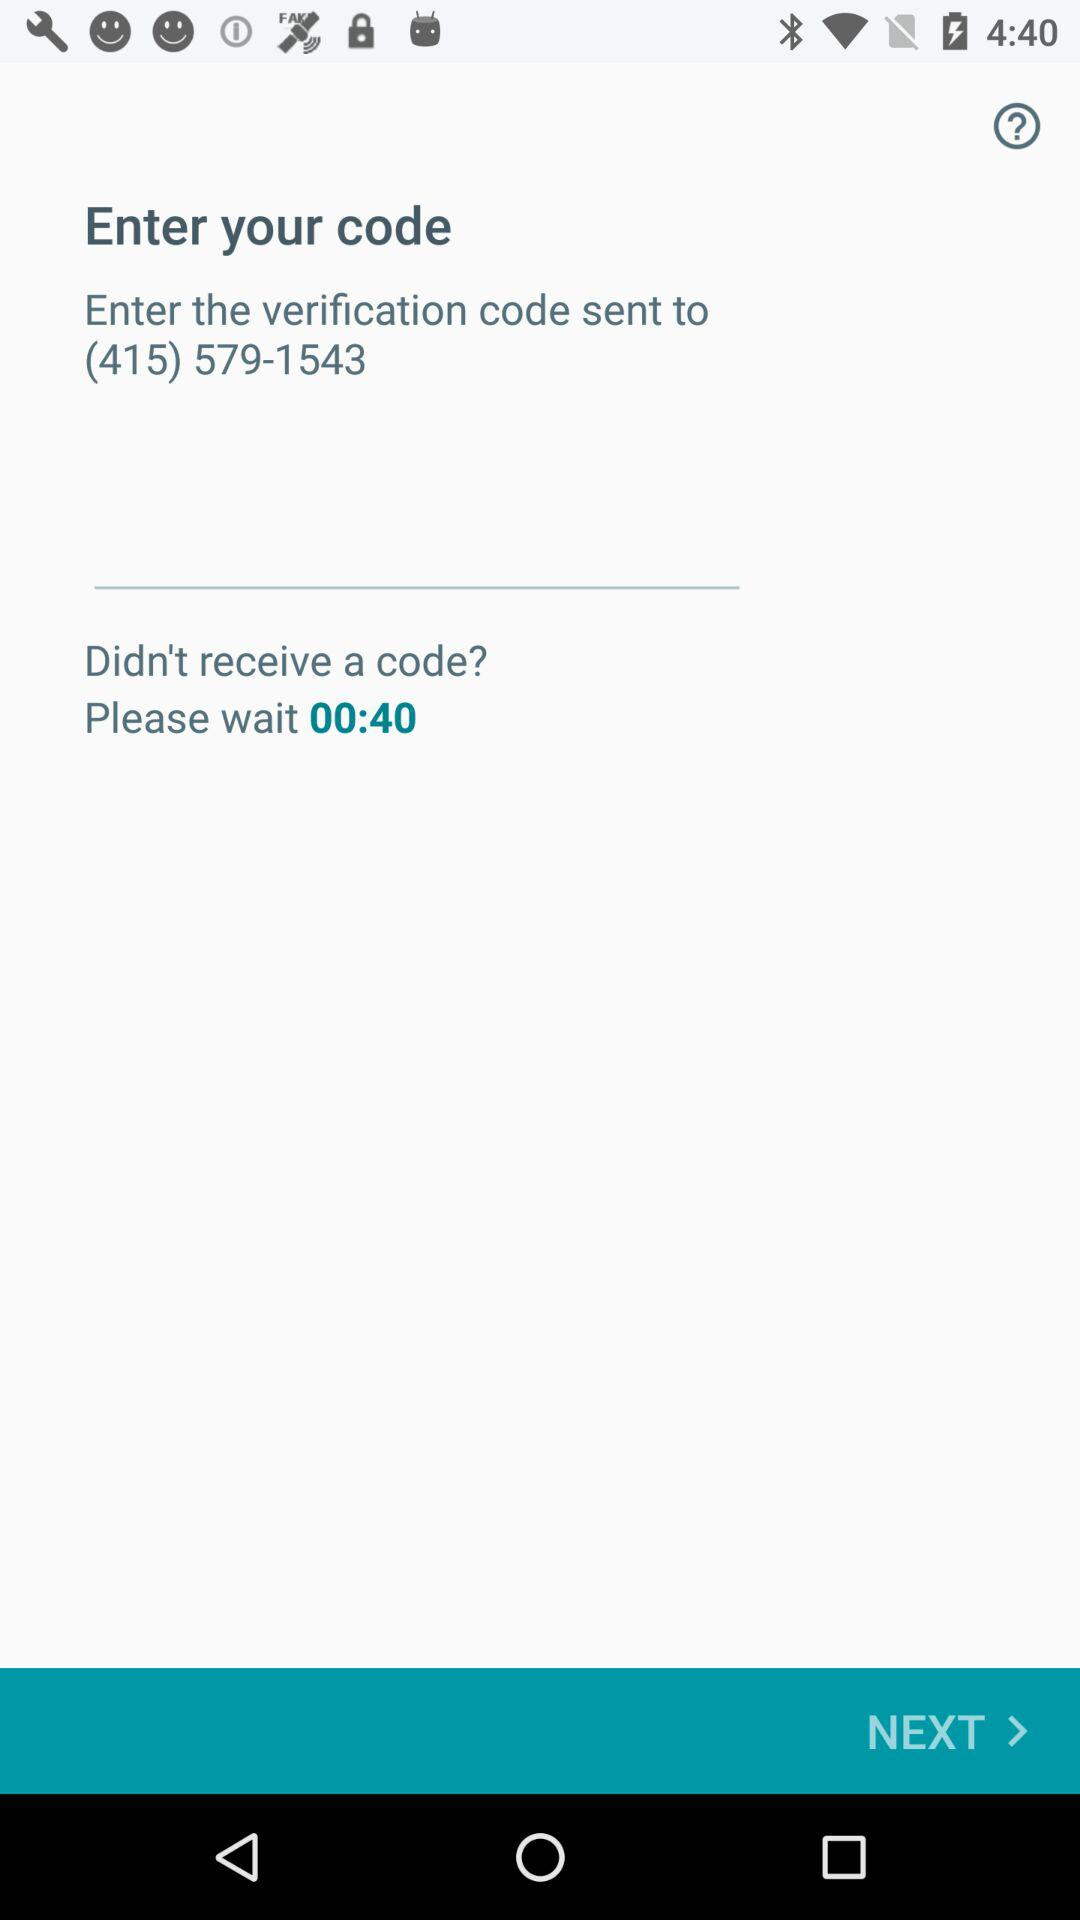How much time is left to receive the code? The remaining time is 40 seconds. 